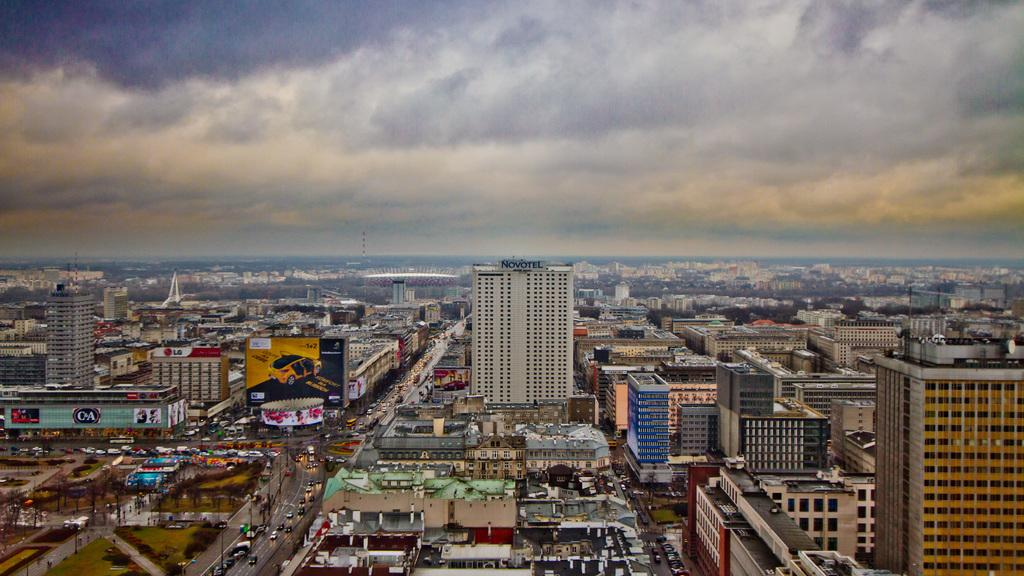What can be seen in the sky in the image? The sky is visible in the image, and clouds are present. What type of structures are in the image? There are buildings in the image. What type of advertisement is present in the image? A hoarding board is present in the image. What type of decorations are visible in the image? Banners are visible in the image. What type of vertical structures are present in the image? Poles are present in the image. What type of transportation is on the road in the image? Vehicles are on the road in the image. What other objects can be seen in the image? There are other objects in the image, but their specific details are not mentioned in the provided facts. What type of gate is blocking the road in the image? There is no gate blocking the road in the image. 